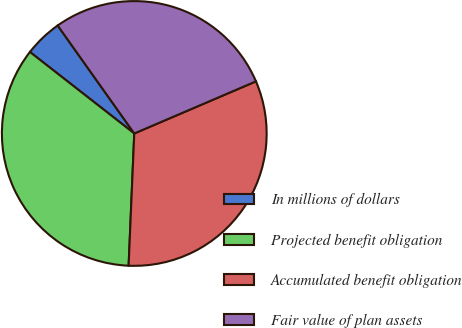<chart> <loc_0><loc_0><loc_500><loc_500><pie_chart><fcel>In millions of dollars<fcel>Projected benefit obligation<fcel>Accumulated benefit obligation<fcel>Fair value of plan assets<nl><fcel>4.63%<fcel>34.87%<fcel>32.12%<fcel>28.38%<nl></chart> 